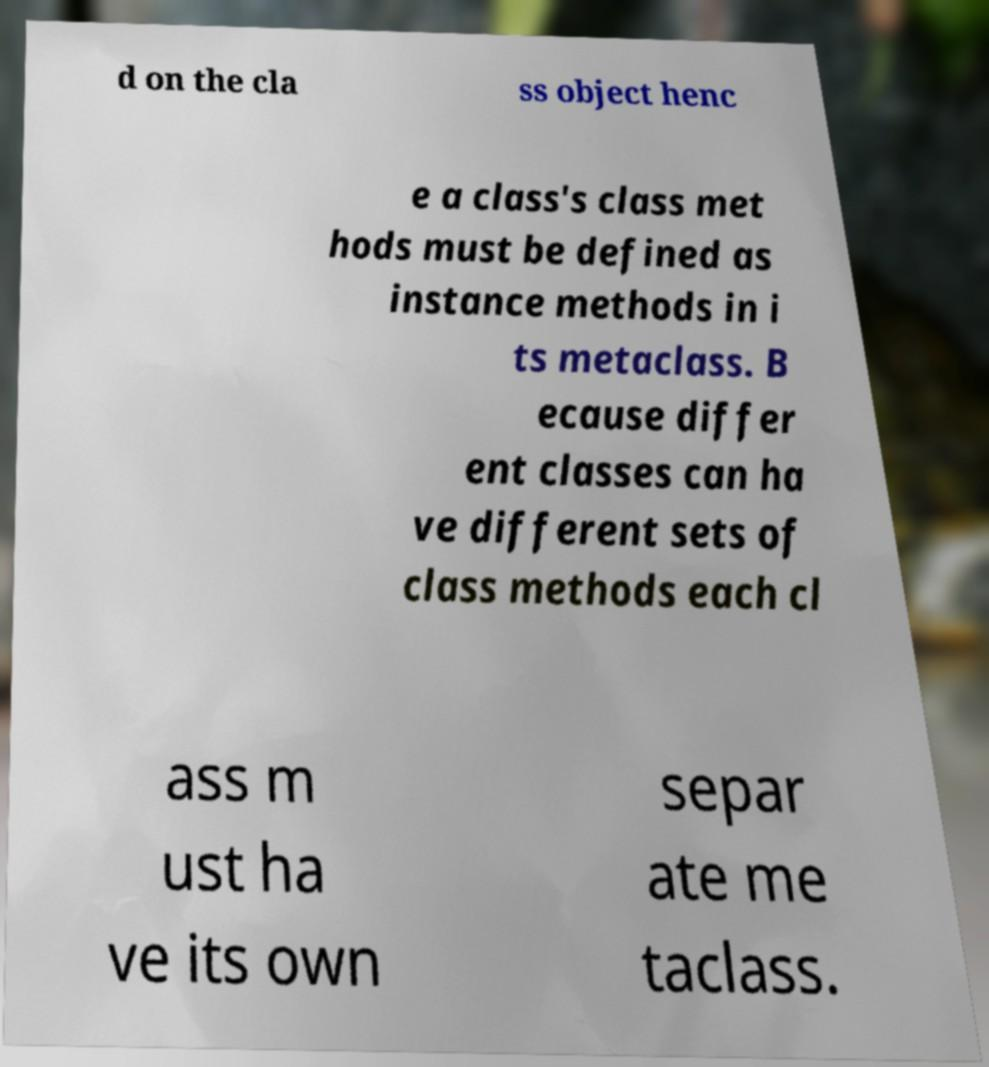For documentation purposes, I need the text within this image transcribed. Could you provide that? d on the cla ss object henc e a class's class met hods must be defined as instance methods in i ts metaclass. B ecause differ ent classes can ha ve different sets of class methods each cl ass m ust ha ve its own separ ate me taclass. 